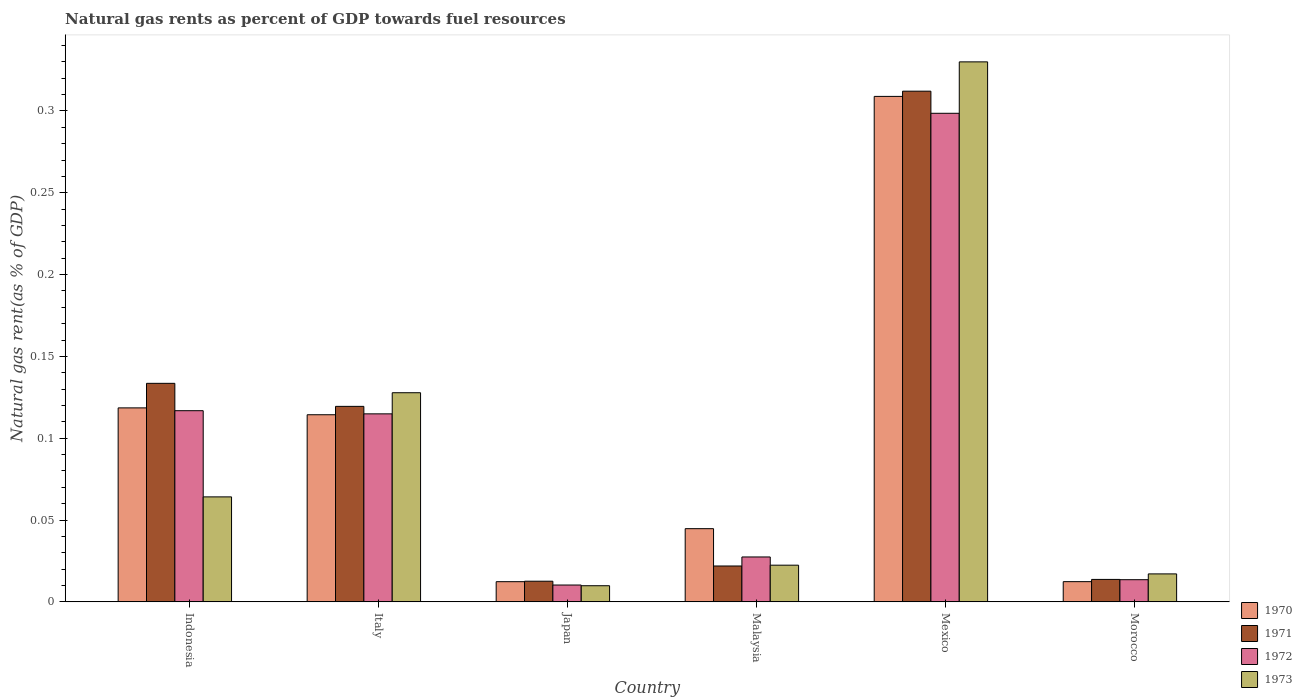Are the number of bars on each tick of the X-axis equal?
Your answer should be very brief. Yes. How many bars are there on the 1st tick from the left?
Keep it short and to the point. 4. How many bars are there on the 4th tick from the right?
Provide a short and direct response. 4. What is the natural gas rent in 1970 in Mexico?
Offer a terse response. 0.31. Across all countries, what is the maximum natural gas rent in 1971?
Ensure brevity in your answer.  0.31. Across all countries, what is the minimum natural gas rent in 1970?
Provide a short and direct response. 0.01. In which country was the natural gas rent in 1972 minimum?
Offer a terse response. Japan. What is the total natural gas rent in 1973 in the graph?
Make the answer very short. 0.57. What is the difference between the natural gas rent in 1970 in Mexico and that in Morocco?
Your answer should be compact. 0.3. What is the difference between the natural gas rent in 1970 in Malaysia and the natural gas rent in 1972 in Indonesia?
Ensure brevity in your answer.  -0.07. What is the average natural gas rent in 1971 per country?
Your answer should be very brief. 0.1. What is the difference between the natural gas rent of/in 1970 and natural gas rent of/in 1973 in Japan?
Offer a very short reply. 0. What is the ratio of the natural gas rent in 1970 in Malaysia to that in Mexico?
Offer a terse response. 0.14. Is the natural gas rent in 1972 in Mexico less than that in Morocco?
Make the answer very short. No. What is the difference between the highest and the second highest natural gas rent in 1970?
Ensure brevity in your answer.  0.19. What is the difference between the highest and the lowest natural gas rent in 1973?
Give a very brief answer. 0.32. In how many countries, is the natural gas rent in 1973 greater than the average natural gas rent in 1973 taken over all countries?
Your answer should be very brief. 2. Is it the case that in every country, the sum of the natural gas rent in 1972 and natural gas rent in 1971 is greater than the sum of natural gas rent in 1973 and natural gas rent in 1970?
Ensure brevity in your answer.  No. What does the 3rd bar from the right in Indonesia represents?
Offer a very short reply. 1971. Is it the case that in every country, the sum of the natural gas rent in 1971 and natural gas rent in 1973 is greater than the natural gas rent in 1972?
Provide a short and direct response. Yes. How many bars are there?
Offer a very short reply. 24. Are the values on the major ticks of Y-axis written in scientific E-notation?
Ensure brevity in your answer.  No. Where does the legend appear in the graph?
Your response must be concise. Bottom right. What is the title of the graph?
Provide a succinct answer. Natural gas rents as percent of GDP towards fuel resources. What is the label or title of the X-axis?
Your answer should be very brief. Country. What is the label or title of the Y-axis?
Your answer should be very brief. Natural gas rent(as % of GDP). What is the Natural gas rent(as % of GDP) in 1970 in Indonesia?
Give a very brief answer. 0.12. What is the Natural gas rent(as % of GDP) in 1971 in Indonesia?
Offer a very short reply. 0.13. What is the Natural gas rent(as % of GDP) of 1972 in Indonesia?
Make the answer very short. 0.12. What is the Natural gas rent(as % of GDP) in 1973 in Indonesia?
Your answer should be very brief. 0.06. What is the Natural gas rent(as % of GDP) of 1970 in Italy?
Give a very brief answer. 0.11. What is the Natural gas rent(as % of GDP) of 1971 in Italy?
Provide a succinct answer. 0.12. What is the Natural gas rent(as % of GDP) in 1972 in Italy?
Offer a very short reply. 0.11. What is the Natural gas rent(as % of GDP) in 1973 in Italy?
Make the answer very short. 0.13. What is the Natural gas rent(as % of GDP) of 1970 in Japan?
Keep it short and to the point. 0.01. What is the Natural gas rent(as % of GDP) of 1971 in Japan?
Keep it short and to the point. 0.01. What is the Natural gas rent(as % of GDP) in 1972 in Japan?
Your answer should be compact. 0.01. What is the Natural gas rent(as % of GDP) of 1973 in Japan?
Your response must be concise. 0.01. What is the Natural gas rent(as % of GDP) of 1970 in Malaysia?
Provide a short and direct response. 0.04. What is the Natural gas rent(as % of GDP) of 1971 in Malaysia?
Offer a terse response. 0.02. What is the Natural gas rent(as % of GDP) of 1972 in Malaysia?
Ensure brevity in your answer.  0.03. What is the Natural gas rent(as % of GDP) of 1973 in Malaysia?
Offer a terse response. 0.02. What is the Natural gas rent(as % of GDP) of 1970 in Mexico?
Provide a succinct answer. 0.31. What is the Natural gas rent(as % of GDP) of 1971 in Mexico?
Give a very brief answer. 0.31. What is the Natural gas rent(as % of GDP) of 1972 in Mexico?
Give a very brief answer. 0.3. What is the Natural gas rent(as % of GDP) in 1973 in Mexico?
Give a very brief answer. 0.33. What is the Natural gas rent(as % of GDP) in 1970 in Morocco?
Offer a terse response. 0.01. What is the Natural gas rent(as % of GDP) of 1971 in Morocco?
Provide a succinct answer. 0.01. What is the Natural gas rent(as % of GDP) of 1972 in Morocco?
Provide a succinct answer. 0.01. What is the Natural gas rent(as % of GDP) in 1973 in Morocco?
Offer a terse response. 0.02. Across all countries, what is the maximum Natural gas rent(as % of GDP) of 1970?
Your response must be concise. 0.31. Across all countries, what is the maximum Natural gas rent(as % of GDP) of 1971?
Make the answer very short. 0.31. Across all countries, what is the maximum Natural gas rent(as % of GDP) in 1972?
Your answer should be very brief. 0.3. Across all countries, what is the maximum Natural gas rent(as % of GDP) in 1973?
Your response must be concise. 0.33. Across all countries, what is the minimum Natural gas rent(as % of GDP) of 1970?
Your response must be concise. 0.01. Across all countries, what is the minimum Natural gas rent(as % of GDP) of 1971?
Your answer should be compact. 0.01. Across all countries, what is the minimum Natural gas rent(as % of GDP) of 1972?
Give a very brief answer. 0.01. Across all countries, what is the minimum Natural gas rent(as % of GDP) in 1973?
Provide a short and direct response. 0.01. What is the total Natural gas rent(as % of GDP) of 1970 in the graph?
Keep it short and to the point. 0.61. What is the total Natural gas rent(as % of GDP) in 1971 in the graph?
Your answer should be very brief. 0.61. What is the total Natural gas rent(as % of GDP) of 1972 in the graph?
Offer a very short reply. 0.58. What is the total Natural gas rent(as % of GDP) of 1973 in the graph?
Make the answer very short. 0.57. What is the difference between the Natural gas rent(as % of GDP) in 1970 in Indonesia and that in Italy?
Your answer should be compact. 0. What is the difference between the Natural gas rent(as % of GDP) of 1971 in Indonesia and that in Italy?
Your answer should be very brief. 0.01. What is the difference between the Natural gas rent(as % of GDP) of 1972 in Indonesia and that in Italy?
Provide a succinct answer. 0. What is the difference between the Natural gas rent(as % of GDP) of 1973 in Indonesia and that in Italy?
Offer a terse response. -0.06. What is the difference between the Natural gas rent(as % of GDP) in 1970 in Indonesia and that in Japan?
Give a very brief answer. 0.11. What is the difference between the Natural gas rent(as % of GDP) of 1971 in Indonesia and that in Japan?
Offer a very short reply. 0.12. What is the difference between the Natural gas rent(as % of GDP) in 1972 in Indonesia and that in Japan?
Provide a short and direct response. 0.11. What is the difference between the Natural gas rent(as % of GDP) in 1973 in Indonesia and that in Japan?
Make the answer very short. 0.05. What is the difference between the Natural gas rent(as % of GDP) of 1970 in Indonesia and that in Malaysia?
Provide a succinct answer. 0.07. What is the difference between the Natural gas rent(as % of GDP) of 1971 in Indonesia and that in Malaysia?
Provide a short and direct response. 0.11. What is the difference between the Natural gas rent(as % of GDP) of 1972 in Indonesia and that in Malaysia?
Offer a terse response. 0.09. What is the difference between the Natural gas rent(as % of GDP) of 1973 in Indonesia and that in Malaysia?
Make the answer very short. 0.04. What is the difference between the Natural gas rent(as % of GDP) of 1970 in Indonesia and that in Mexico?
Offer a terse response. -0.19. What is the difference between the Natural gas rent(as % of GDP) in 1971 in Indonesia and that in Mexico?
Give a very brief answer. -0.18. What is the difference between the Natural gas rent(as % of GDP) in 1972 in Indonesia and that in Mexico?
Ensure brevity in your answer.  -0.18. What is the difference between the Natural gas rent(as % of GDP) in 1973 in Indonesia and that in Mexico?
Your answer should be compact. -0.27. What is the difference between the Natural gas rent(as % of GDP) of 1970 in Indonesia and that in Morocco?
Ensure brevity in your answer.  0.11. What is the difference between the Natural gas rent(as % of GDP) in 1971 in Indonesia and that in Morocco?
Your response must be concise. 0.12. What is the difference between the Natural gas rent(as % of GDP) in 1972 in Indonesia and that in Morocco?
Ensure brevity in your answer.  0.1. What is the difference between the Natural gas rent(as % of GDP) in 1973 in Indonesia and that in Morocco?
Make the answer very short. 0.05. What is the difference between the Natural gas rent(as % of GDP) in 1970 in Italy and that in Japan?
Offer a very short reply. 0.1. What is the difference between the Natural gas rent(as % of GDP) in 1971 in Italy and that in Japan?
Make the answer very short. 0.11. What is the difference between the Natural gas rent(as % of GDP) of 1972 in Italy and that in Japan?
Keep it short and to the point. 0.1. What is the difference between the Natural gas rent(as % of GDP) in 1973 in Italy and that in Japan?
Your answer should be very brief. 0.12. What is the difference between the Natural gas rent(as % of GDP) of 1970 in Italy and that in Malaysia?
Provide a succinct answer. 0.07. What is the difference between the Natural gas rent(as % of GDP) in 1971 in Italy and that in Malaysia?
Your answer should be very brief. 0.1. What is the difference between the Natural gas rent(as % of GDP) in 1972 in Italy and that in Malaysia?
Offer a terse response. 0.09. What is the difference between the Natural gas rent(as % of GDP) in 1973 in Italy and that in Malaysia?
Ensure brevity in your answer.  0.11. What is the difference between the Natural gas rent(as % of GDP) in 1970 in Italy and that in Mexico?
Your answer should be compact. -0.19. What is the difference between the Natural gas rent(as % of GDP) of 1971 in Italy and that in Mexico?
Make the answer very short. -0.19. What is the difference between the Natural gas rent(as % of GDP) in 1972 in Italy and that in Mexico?
Your response must be concise. -0.18. What is the difference between the Natural gas rent(as % of GDP) in 1973 in Italy and that in Mexico?
Make the answer very short. -0.2. What is the difference between the Natural gas rent(as % of GDP) in 1970 in Italy and that in Morocco?
Ensure brevity in your answer.  0.1. What is the difference between the Natural gas rent(as % of GDP) in 1971 in Italy and that in Morocco?
Your answer should be compact. 0.11. What is the difference between the Natural gas rent(as % of GDP) in 1972 in Italy and that in Morocco?
Offer a terse response. 0.1. What is the difference between the Natural gas rent(as % of GDP) in 1973 in Italy and that in Morocco?
Give a very brief answer. 0.11. What is the difference between the Natural gas rent(as % of GDP) of 1970 in Japan and that in Malaysia?
Your response must be concise. -0.03. What is the difference between the Natural gas rent(as % of GDP) of 1971 in Japan and that in Malaysia?
Your answer should be compact. -0.01. What is the difference between the Natural gas rent(as % of GDP) of 1972 in Japan and that in Malaysia?
Your answer should be compact. -0.02. What is the difference between the Natural gas rent(as % of GDP) in 1973 in Japan and that in Malaysia?
Provide a short and direct response. -0.01. What is the difference between the Natural gas rent(as % of GDP) in 1970 in Japan and that in Mexico?
Offer a terse response. -0.3. What is the difference between the Natural gas rent(as % of GDP) in 1971 in Japan and that in Mexico?
Your answer should be compact. -0.3. What is the difference between the Natural gas rent(as % of GDP) in 1972 in Japan and that in Mexico?
Give a very brief answer. -0.29. What is the difference between the Natural gas rent(as % of GDP) in 1973 in Japan and that in Mexico?
Make the answer very short. -0.32. What is the difference between the Natural gas rent(as % of GDP) of 1971 in Japan and that in Morocco?
Offer a very short reply. -0. What is the difference between the Natural gas rent(as % of GDP) of 1972 in Japan and that in Morocco?
Offer a terse response. -0. What is the difference between the Natural gas rent(as % of GDP) of 1973 in Japan and that in Morocco?
Your answer should be compact. -0.01. What is the difference between the Natural gas rent(as % of GDP) in 1970 in Malaysia and that in Mexico?
Provide a short and direct response. -0.26. What is the difference between the Natural gas rent(as % of GDP) in 1971 in Malaysia and that in Mexico?
Provide a short and direct response. -0.29. What is the difference between the Natural gas rent(as % of GDP) of 1972 in Malaysia and that in Mexico?
Offer a very short reply. -0.27. What is the difference between the Natural gas rent(as % of GDP) of 1973 in Malaysia and that in Mexico?
Your answer should be compact. -0.31. What is the difference between the Natural gas rent(as % of GDP) of 1970 in Malaysia and that in Morocco?
Provide a short and direct response. 0.03. What is the difference between the Natural gas rent(as % of GDP) of 1971 in Malaysia and that in Morocco?
Make the answer very short. 0.01. What is the difference between the Natural gas rent(as % of GDP) in 1972 in Malaysia and that in Morocco?
Ensure brevity in your answer.  0.01. What is the difference between the Natural gas rent(as % of GDP) of 1973 in Malaysia and that in Morocco?
Your answer should be compact. 0.01. What is the difference between the Natural gas rent(as % of GDP) of 1970 in Mexico and that in Morocco?
Ensure brevity in your answer.  0.3. What is the difference between the Natural gas rent(as % of GDP) in 1971 in Mexico and that in Morocco?
Provide a short and direct response. 0.3. What is the difference between the Natural gas rent(as % of GDP) of 1972 in Mexico and that in Morocco?
Your answer should be compact. 0.28. What is the difference between the Natural gas rent(as % of GDP) of 1973 in Mexico and that in Morocco?
Provide a short and direct response. 0.31. What is the difference between the Natural gas rent(as % of GDP) in 1970 in Indonesia and the Natural gas rent(as % of GDP) in 1971 in Italy?
Offer a terse response. -0. What is the difference between the Natural gas rent(as % of GDP) of 1970 in Indonesia and the Natural gas rent(as % of GDP) of 1972 in Italy?
Your response must be concise. 0. What is the difference between the Natural gas rent(as % of GDP) of 1970 in Indonesia and the Natural gas rent(as % of GDP) of 1973 in Italy?
Give a very brief answer. -0.01. What is the difference between the Natural gas rent(as % of GDP) of 1971 in Indonesia and the Natural gas rent(as % of GDP) of 1972 in Italy?
Give a very brief answer. 0.02. What is the difference between the Natural gas rent(as % of GDP) of 1971 in Indonesia and the Natural gas rent(as % of GDP) of 1973 in Italy?
Give a very brief answer. 0.01. What is the difference between the Natural gas rent(as % of GDP) of 1972 in Indonesia and the Natural gas rent(as % of GDP) of 1973 in Italy?
Offer a very short reply. -0.01. What is the difference between the Natural gas rent(as % of GDP) in 1970 in Indonesia and the Natural gas rent(as % of GDP) in 1971 in Japan?
Your answer should be compact. 0.11. What is the difference between the Natural gas rent(as % of GDP) of 1970 in Indonesia and the Natural gas rent(as % of GDP) of 1972 in Japan?
Your answer should be very brief. 0.11. What is the difference between the Natural gas rent(as % of GDP) in 1970 in Indonesia and the Natural gas rent(as % of GDP) in 1973 in Japan?
Make the answer very short. 0.11. What is the difference between the Natural gas rent(as % of GDP) in 1971 in Indonesia and the Natural gas rent(as % of GDP) in 1972 in Japan?
Provide a short and direct response. 0.12. What is the difference between the Natural gas rent(as % of GDP) in 1971 in Indonesia and the Natural gas rent(as % of GDP) in 1973 in Japan?
Your response must be concise. 0.12. What is the difference between the Natural gas rent(as % of GDP) of 1972 in Indonesia and the Natural gas rent(as % of GDP) of 1973 in Japan?
Your answer should be very brief. 0.11. What is the difference between the Natural gas rent(as % of GDP) of 1970 in Indonesia and the Natural gas rent(as % of GDP) of 1971 in Malaysia?
Provide a short and direct response. 0.1. What is the difference between the Natural gas rent(as % of GDP) of 1970 in Indonesia and the Natural gas rent(as % of GDP) of 1972 in Malaysia?
Keep it short and to the point. 0.09. What is the difference between the Natural gas rent(as % of GDP) in 1970 in Indonesia and the Natural gas rent(as % of GDP) in 1973 in Malaysia?
Provide a succinct answer. 0.1. What is the difference between the Natural gas rent(as % of GDP) in 1971 in Indonesia and the Natural gas rent(as % of GDP) in 1972 in Malaysia?
Make the answer very short. 0.11. What is the difference between the Natural gas rent(as % of GDP) of 1972 in Indonesia and the Natural gas rent(as % of GDP) of 1973 in Malaysia?
Give a very brief answer. 0.09. What is the difference between the Natural gas rent(as % of GDP) in 1970 in Indonesia and the Natural gas rent(as % of GDP) in 1971 in Mexico?
Offer a very short reply. -0.19. What is the difference between the Natural gas rent(as % of GDP) of 1970 in Indonesia and the Natural gas rent(as % of GDP) of 1972 in Mexico?
Keep it short and to the point. -0.18. What is the difference between the Natural gas rent(as % of GDP) in 1970 in Indonesia and the Natural gas rent(as % of GDP) in 1973 in Mexico?
Give a very brief answer. -0.21. What is the difference between the Natural gas rent(as % of GDP) in 1971 in Indonesia and the Natural gas rent(as % of GDP) in 1972 in Mexico?
Offer a very short reply. -0.17. What is the difference between the Natural gas rent(as % of GDP) of 1971 in Indonesia and the Natural gas rent(as % of GDP) of 1973 in Mexico?
Provide a short and direct response. -0.2. What is the difference between the Natural gas rent(as % of GDP) of 1972 in Indonesia and the Natural gas rent(as % of GDP) of 1973 in Mexico?
Make the answer very short. -0.21. What is the difference between the Natural gas rent(as % of GDP) of 1970 in Indonesia and the Natural gas rent(as % of GDP) of 1971 in Morocco?
Your answer should be very brief. 0.1. What is the difference between the Natural gas rent(as % of GDP) in 1970 in Indonesia and the Natural gas rent(as % of GDP) in 1972 in Morocco?
Your answer should be very brief. 0.1. What is the difference between the Natural gas rent(as % of GDP) in 1970 in Indonesia and the Natural gas rent(as % of GDP) in 1973 in Morocco?
Your answer should be very brief. 0.1. What is the difference between the Natural gas rent(as % of GDP) of 1971 in Indonesia and the Natural gas rent(as % of GDP) of 1972 in Morocco?
Your response must be concise. 0.12. What is the difference between the Natural gas rent(as % of GDP) of 1971 in Indonesia and the Natural gas rent(as % of GDP) of 1973 in Morocco?
Your answer should be very brief. 0.12. What is the difference between the Natural gas rent(as % of GDP) in 1972 in Indonesia and the Natural gas rent(as % of GDP) in 1973 in Morocco?
Your answer should be compact. 0.1. What is the difference between the Natural gas rent(as % of GDP) of 1970 in Italy and the Natural gas rent(as % of GDP) of 1971 in Japan?
Provide a short and direct response. 0.1. What is the difference between the Natural gas rent(as % of GDP) of 1970 in Italy and the Natural gas rent(as % of GDP) of 1972 in Japan?
Your answer should be compact. 0.1. What is the difference between the Natural gas rent(as % of GDP) of 1970 in Italy and the Natural gas rent(as % of GDP) of 1973 in Japan?
Provide a short and direct response. 0.1. What is the difference between the Natural gas rent(as % of GDP) of 1971 in Italy and the Natural gas rent(as % of GDP) of 1972 in Japan?
Your answer should be very brief. 0.11. What is the difference between the Natural gas rent(as % of GDP) in 1971 in Italy and the Natural gas rent(as % of GDP) in 1973 in Japan?
Provide a succinct answer. 0.11. What is the difference between the Natural gas rent(as % of GDP) of 1972 in Italy and the Natural gas rent(as % of GDP) of 1973 in Japan?
Make the answer very short. 0.1. What is the difference between the Natural gas rent(as % of GDP) in 1970 in Italy and the Natural gas rent(as % of GDP) in 1971 in Malaysia?
Provide a succinct answer. 0.09. What is the difference between the Natural gas rent(as % of GDP) in 1970 in Italy and the Natural gas rent(as % of GDP) in 1972 in Malaysia?
Provide a short and direct response. 0.09. What is the difference between the Natural gas rent(as % of GDP) of 1970 in Italy and the Natural gas rent(as % of GDP) of 1973 in Malaysia?
Your answer should be very brief. 0.09. What is the difference between the Natural gas rent(as % of GDP) in 1971 in Italy and the Natural gas rent(as % of GDP) in 1972 in Malaysia?
Provide a succinct answer. 0.09. What is the difference between the Natural gas rent(as % of GDP) in 1971 in Italy and the Natural gas rent(as % of GDP) in 1973 in Malaysia?
Provide a short and direct response. 0.1. What is the difference between the Natural gas rent(as % of GDP) of 1972 in Italy and the Natural gas rent(as % of GDP) of 1973 in Malaysia?
Provide a succinct answer. 0.09. What is the difference between the Natural gas rent(as % of GDP) in 1970 in Italy and the Natural gas rent(as % of GDP) in 1971 in Mexico?
Keep it short and to the point. -0.2. What is the difference between the Natural gas rent(as % of GDP) of 1970 in Italy and the Natural gas rent(as % of GDP) of 1972 in Mexico?
Your response must be concise. -0.18. What is the difference between the Natural gas rent(as % of GDP) in 1970 in Italy and the Natural gas rent(as % of GDP) in 1973 in Mexico?
Provide a succinct answer. -0.22. What is the difference between the Natural gas rent(as % of GDP) of 1971 in Italy and the Natural gas rent(as % of GDP) of 1972 in Mexico?
Your answer should be very brief. -0.18. What is the difference between the Natural gas rent(as % of GDP) in 1971 in Italy and the Natural gas rent(as % of GDP) in 1973 in Mexico?
Provide a succinct answer. -0.21. What is the difference between the Natural gas rent(as % of GDP) in 1972 in Italy and the Natural gas rent(as % of GDP) in 1973 in Mexico?
Give a very brief answer. -0.22. What is the difference between the Natural gas rent(as % of GDP) in 1970 in Italy and the Natural gas rent(as % of GDP) in 1971 in Morocco?
Give a very brief answer. 0.1. What is the difference between the Natural gas rent(as % of GDP) in 1970 in Italy and the Natural gas rent(as % of GDP) in 1972 in Morocco?
Offer a terse response. 0.1. What is the difference between the Natural gas rent(as % of GDP) in 1970 in Italy and the Natural gas rent(as % of GDP) in 1973 in Morocco?
Keep it short and to the point. 0.1. What is the difference between the Natural gas rent(as % of GDP) of 1971 in Italy and the Natural gas rent(as % of GDP) of 1972 in Morocco?
Ensure brevity in your answer.  0.11. What is the difference between the Natural gas rent(as % of GDP) in 1971 in Italy and the Natural gas rent(as % of GDP) in 1973 in Morocco?
Provide a succinct answer. 0.1. What is the difference between the Natural gas rent(as % of GDP) in 1972 in Italy and the Natural gas rent(as % of GDP) in 1973 in Morocco?
Your response must be concise. 0.1. What is the difference between the Natural gas rent(as % of GDP) in 1970 in Japan and the Natural gas rent(as % of GDP) in 1971 in Malaysia?
Your response must be concise. -0.01. What is the difference between the Natural gas rent(as % of GDP) in 1970 in Japan and the Natural gas rent(as % of GDP) in 1972 in Malaysia?
Provide a succinct answer. -0.02. What is the difference between the Natural gas rent(as % of GDP) of 1970 in Japan and the Natural gas rent(as % of GDP) of 1973 in Malaysia?
Offer a very short reply. -0.01. What is the difference between the Natural gas rent(as % of GDP) of 1971 in Japan and the Natural gas rent(as % of GDP) of 1972 in Malaysia?
Your answer should be compact. -0.01. What is the difference between the Natural gas rent(as % of GDP) of 1971 in Japan and the Natural gas rent(as % of GDP) of 1973 in Malaysia?
Provide a short and direct response. -0.01. What is the difference between the Natural gas rent(as % of GDP) in 1972 in Japan and the Natural gas rent(as % of GDP) in 1973 in Malaysia?
Ensure brevity in your answer.  -0.01. What is the difference between the Natural gas rent(as % of GDP) of 1970 in Japan and the Natural gas rent(as % of GDP) of 1971 in Mexico?
Offer a terse response. -0.3. What is the difference between the Natural gas rent(as % of GDP) of 1970 in Japan and the Natural gas rent(as % of GDP) of 1972 in Mexico?
Give a very brief answer. -0.29. What is the difference between the Natural gas rent(as % of GDP) of 1970 in Japan and the Natural gas rent(as % of GDP) of 1973 in Mexico?
Make the answer very short. -0.32. What is the difference between the Natural gas rent(as % of GDP) in 1971 in Japan and the Natural gas rent(as % of GDP) in 1972 in Mexico?
Provide a short and direct response. -0.29. What is the difference between the Natural gas rent(as % of GDP) of 1971 in Japan and the Natural gas rent(as % of GDP) of 1973 in Mexico?
Offer a terse response. -0.32. What is the difference between the Natural gas rent(as % of GDP) in 1972 in Japan and the Natural gas rent(as % of GDP) in 1973 in Mexico?
Give a very brief answer. -0.32. What is the difference between the Natural gas rent(as % of GDP) of 1970 in Japan and the Natural gas rent(as % of GDP) of 1971 in Morocco?
Give a very brief answer. -0. What is the difference between the Natural gas rent(as % of GDP) in 1970 in Japan and the Natural gas rent(as % of GDP) in 1972 in Morocco?
Provide a succinct answer. -0. What is the difference between the Natural gas rent(as % of GDP) in 1970 in Japan and the Natural gas rent(as % of GDP) in 1973 in Morocco?
Your answer should be very brief. -0. What is the difference between the Natural gas rent(as % of GDP) in 1971 in Japan and the Natural gas rent(as % of GDP) in 1972 in Morocco?
Provide a succinct answer. -0. What is the difference between the Natural gas rent(as % of GDP) in 1971 in Japan and the Natural gas rent(as % of GDP) in 1973 in Morocco?
Your answer should be very brief. -0. What is the difference between the Natural gas rent(as % of GDP) of 1972 in Japan and the Natural gas rent(as % of GDP) of 1973 in Morocco?
Your answer should be compact. -0.01. What is the difference between the Natural gas rent(as % of GDP) in 1970 in Malaysia and the Natural gas rent(as % of GDP) in 1971 in Mexico?
Keep it short and to the point. -0.27. What is the difference between the Natural gas rent(as % of GDP) in 1970 in Malaysia and the Natural gas rent(as % of GDP) in 1972 in Mexico?
Provide a short and direct response. -0.25. What is the difference between the Natural gas rent(as % of GDP) of 1970 in Malaysia and the Natural gas rent(as % of GDP) of 1973 in Mexico?
Make the answer very short. -0.29. What is the difference between the Natural gas rent(as % of GDP) of 1971 in Malaysia and the Natural gas rent(as % of GDP) of 1972 in Mexico?
Ensure brevity in your answer.  -0.28. What is the difference between the Natural gas rent(as % of GDP) in 1971 in Malaysia and the Natural gas rent(as % of GDP) in 1973 in Mexico?
Provide a succinct answer. -0.31. What is the difference between the Natural gas rent(as % of GDP) in 1972 in Malaysia and the Natural gas rent(as % of GDP) in 1973 in Mexico?
Provide a short and direct response. -0.3. What is the difference between the Natural gas rent(as % of GDP) in 1970 in Malaysia and the Natural gas rent(as % of GDP) in 1971 in Morocco?
Give a very brief answer. 0.03. What is the difference between the Natural gas rent(as % of GDP) of 1970 in Malaysia and the Natural gas rent(as % of GDP) of 1972 in Morocco?
Your response must be concise. 0.03. What is the difference between the Natural gas rent(as % of GDP) of 1970 in Malaysia and the Natural gas rent(as % of GDP) of 1973 in Morocco?
Your answer should be compact. 0.03. What is the difference between the Natural gas rent(as % of GDP) of 1971 in Malaysia and the Natural gas rent(as % of GDP) of 1972 in Morocco?
Give a very brief answer. 0.01. What is the difference between the Natural gas rent(as % of GDP) of 1971 in Malaysia and the Natural gas rent(as % of GDP) of 1973 in Morocco?
Give a very brief answer. 0. What is the difference between the Natural gas rent(as % of GDP) in 1972 in Malaysia and the Natural gas rent(as % of GDP) in 1973 in Morocco?
Keep it short and to the point. 0.01. What is the difference between the Natural gas rent(as % of GDP) in 1970 in Mexico and the Natural gas rent(as % of GDP) in 1971 in Morocco?
Keep it short and to the point. 0.3. What is the difference between the Natural gas rent(as % of GDP) in 1970 in Mexico and the Natural gas rent(as % of GDP) in 1972 in Morocco?
Ensure brevity in your answer.  0.3. What is the difference between the Natural gas rent(as % of GDP) of 1970 in Mexico and the Natural gas rent(as % of GDP) of 1973 in Morocco?
Provide a short and direct response. 0.29. What is the difference between the Natural gas rent(as % of GDP) in 1971 in Mexico and the Natural gas rent(as % of GDP) in 1972 in Morocco?
Make the answer very short. 0.3. What is the difference between the Natural gas rent(as % of GDP) in 1971 in Mexico and the Natural gas rent(as % of GDP) in 1973 in Morocco?
Your response must be concise. 0.29. What is the difference between the Natural gas rent(as % of GDP) in 1972 in Mexico and the Natural gas rent(as % of GDP) in 1973 in Morocco?
Offer a terse response. 0.28. What is the average Natural gas rent(as % of GDP) of 1970 per country?
Your response must be concise. 0.1. What is the average Natural gas rent(as % of GDP) of 1971 per country?
Your answer should be compact. 0.1. What is the average Natural gas rent(as % of GDP) of 1972 per country?
Make the answer very short. 0.1. What is the average Natural gas rent(as % of GDP) of 1973 per country?
Keep it short and to the point. 0.1. What is the difference between the Natural gas rent(as % of GDP) of 1970 and Natural gas rent(as % of GDP) of 1971 in Indonesia?
Provide a short and direct response. -0.01. What is the difference between the Natural gas rent(as % of GDP) of 1970 and Natural gas rent(as % of GDP) of 1972 in Indonesia?
Your response must be concise. 0. What is the difference between the Natural gas rent(as % of GDP) in 1970 and Natural gas rent(as % of GDP) in 1973 in Indonesia?
Provide a short and direct response. 0.05. What is the difference between the Natural gas rent(as % of GDP) of 1971 and Natural gas rent(as % of GDP) of 1972 in Indonesia?
Make the answer very short. 0.02. What is the difference between the Natural gas rent(as % of GDP) of 1971 and Natural gas rent(as % of GDP) of 1973 in Indonesia?
Ensure brevity in your answer.  0.07. What is the difference between the Natural gas rent(as % of GDP) in 1972 and Natural gas rent(as % of GDP) in 1973 in Indonesia?
Offer a terse response. 0.05. What is the difference between the Natural gas rent(as % of GDP) of 1970 and Natural gas rent(as % of GDP) of 1971 in Italy?
Make the answer very short. -0.01. What is the difference between the Natural gas rent(as % of GDP) in 1970 and Natural gas rent(as % of GDP) in 1972 in Italy?
Keep it short and to the point. -0. What is the difference between the Natural gas rent(as % of GDP) of 1970 and Natural gas rent(as % of GDP) of 1973 in Italy?
Offer a terse response. -0.01. What is the difference between the Natural gas rent(as % of GDP) of 1971 and Natural gas rent(as % of GDP) of 1972 in Italy?
Make the answer very short. 0. What is the difference between the Natural gas rent(as % of GDP) in 1971 and Natural gas rent(as % of GDP) in 1973 in Italy?
Provide a short and direct response. -0.01. What is the difference between the Natural gas rent(as % of GDP) in 1972 and Natural gas rent(as % of GDP) in 1973 in Italy?
Your answer should be compact. -0.01. What is the difference between the Natural gas rent(as % of GDP) in 1970 and Natural gas rent(as % of GDP) in 1971 in Japan?
Make the answer very short. -0. What is the difference between the Natural gas rent(as % of GDP) of 1970 and Natural gas rent(as % of GDP) of 1972 in Japan?
Provide a succinct answer. 0. What is the difference between the Natural gas rent(as % of GDP) in 1970 and Natural gas rent(as % of GDP) in 1973 in Japan?
Provide a short and direct response. 0. What is the difference between the Natural gas rent(as % of GDP) in 1971 and Natural gas rent(as % of GDP) in 1972 in Japan?
Provide a short and direct response. 0. What is the difference between the Natural gas rent(as % of GDP) in 1971 and Natural gas rent(as % of GDP) in 1973 in Japan?
Offer a very short reply. 0. What is the difference between the Natural gas rent(as % of GDP) of 1972 and Natural gas rent(as % of GDP) of 1973 in Japan?
Offer a very short reply. 0. What is the difference between the Natural gas rent(as % of GDP) in 1970 and Natural gas rent(as % of GDP) in 1971 in Malaysia?
Your answer should be compact. 0.02. What is the difference between the Natural gas rent(as % of GDP) in 1970 and Natural gas rent(as % of GDP) in 1972 in Malaysia?
Your response must be concise. 0.02. What is the difference between the Natural gas rent(as % of GDP) of 1970 and Natural gas rent(as % of GDP) of 1973 in Malaysia?
Your response must be concise. 0.02. What is the difference between the Natural gas rent(as % of GDP) in 1971 and Natural gas rent(as % of GDP) in 1972 in Malaysia?
Your answer should be compact. -0.01. What is the difference between the Natural gas rent(as % of GDP) of 1971 and Natural gas rent(as % of GDP) of 1973 in Malaysia?
Your answer should be compact. -0. What is the difference between the Natural gas rent(as % of GDP) of 1972 and Natural gas rent(as % of GDP) of 1973 in Malaysia?
Provide a short and direct response. 0.01. What is the difference between the Natural gas rent(as % of GDP) in 1970 and Natural gas rent(as % of GDP) in 1971 in Mexico?
Make the answer very short. -0. What is the difference between the Natural gas rent(as % of GDP) in 1970 and Natural gas rent(as % of GDP) in 1972 in Mexico?
Offer a very short reply. 0.01. What is the difference between the Natural gas rent(as % of GDP) of 1970 and Natural gas rent(as % of GDP) of 1973 in Mexico?
Your answer should be very brief. -0.02. What is the difference between the Natural gas rent(as % of GDP) of 1971 and Natural gas rent(as % of GDP) of 1972 in Mexico?
Provide a short and direct response. 0.01. What is the difference between the Natural gas rent(as % of GDP) in 1971 and Natural gas rent(as % of GDP) in 1973 in Mexico?
Your answer should be very brief. -0.02. What is the difference between the Natural gas rent(as % of GDP) of 1972 and Natural gas rent(as % of GDP) of 1973 in Mexico?
Offer a terse response. -0.03. What is the difference between the Natural gas rent(as % of GDP) of 1970 and Natural gas rent(as % of GDP) of 1971 in Morocco?
Make the answer very short. -0. What is the difference between the Natural gas rent(as % of GDP) in 1970 and Natural gas rent(as % of GDP) in 1972 in Morocco?
Keep it short and to the point. -0. What is the difference between the Natural gas rent(as % of GDP) in 1970 and Natural gas rent(as % of GDP) in 1973 in Morocco?
Offer a very short reply. -0. What is the difference between the Natural gas rent(as % of GDP) in 1971 and Natural gas rent(as % of GDP) in 1972 in Morocco?
Ensure brevity in your answer.  0. What is the difference between the Natural gas rent(as % of GDP) of 1971 and Natural gas rent(as % of GDP) of 1973 in Morocco?
Provide a succinct answer. -0. What is the difference between the Natural gas rent(as % of GDP) of 1972 and Natural gas rent(as % of GDP) of 1973 in Morocco?
Offer a terse response. -0. What is the ratio of the Natural gas rent(as % of GDP) in 1970 in Indonesia to that in Italy?
Offer a very short reply. 1.04. What is the ratio of the Natural gas rent(as % of GDP) in 1971 in Indonesia to that in Italy?
Offer a very short reply. 1.12. What is the ratio of the Natural gas rent(as % of GDP) in 1972 in Indonesia to that in Italy?
Your answer should be compact. 1.02. What is the ratio of the Natural gas rent(as % of GDP) in 1973 in Indonesia to that in Italy?
Give a very brief answer. 0.5. What is the ratio of the Natural gas rent(as % of GDP) in 1970 in Indonesia to that in Japan?
Your answer should be very brief. 9.61. What is the ratio of the Natural gas rent(as % of GDP) in 1971 in Indonesia to that in Japan?
Keep it short and to the point. 10.58. What is the ratio of the Natural gas rent(as % of GDP) of 1972 in Indonesia to that in Japan?
Give a very brief answer. 11.34. What is the ratio of the Natural gas rent(as % of GDP) of 1973 in Indonesia to that in Japan?
Your answer should be very brief. 6.5. What is the ratio of the Natural gas rent(as % of GDP) of 1970 in Indonesia to that in Malaysia?
Provide a succinct answer. 2.65. What is the ratio of the Natural gas rent(as % of GDP) in 1971 in Indonesia to that in Malaysia?
Keep it short and to the point. 6.09. What is the ratio of the Natural gas rent(as % of GDP) in 1972 in Indonesia to that in Malaysia?
Provide a short and direct response. 4.26. What is the ratio of the Natural gas rent(as % of GDP) of 1973 in Indonesia to that in Malaysia?
Your answer should be compact. 2.86. What is the ratio of the Natural gas rent(as % of GDP) in 1970 in Indonesia to that in Mexico?
Offer a terse response. 0.38. What is the ratio of the Natural gas rent(as % of GDP) of 1971 in Indonesia to that in Mexico?
Make the answer very short. 0.43. What is the ratio of the Natural gas rent(as % of GDP) of 1972 in Indonesia to that in Mexico?
Provide a succinct answer. 0.39. What is the ratio of the Natural gas rent(as % of GDP) of 1973 in Indonesia to that in Mexico?
Make the answer very short. 0.19. What is the ratio of the Natural gas rent(as % of GDP) of 1970 in Indonesia to that in Morocco?
Your response must be concise. 9.59. What is the ratio of the Natural gas rent(as % of GDP) in 1971 in Indonesia to that in Morocco?
Your answer should be compact. 9.73. What is the ratio of the Natural gas rent(as % of GDP) of 1972 in Indonesia to that in Morocco?
Offer a terse response. 8.62. What is the ratio of the Natural gas rent(as % of GDP) of 1973 in Indonesia to that in Morocco?
Provide a short and direct response. 3.75. What is the ratio of the Natural gas rent(as % of GDP) of 1970 in Italy to that in Japan?
Keep it short and to the point. 9.27. What is the ratio of the Natural gas rent(as % of GDP) of 1971 in Italy to that in Japan?
Your answer should be compact. 9.46. What is the ratio of the Natural gas rent(as % of GDP) in 1972 in Italy to that in Japan?
Make the answer very short. 11.16. What is the ratio of the Natural gas rent(as % of GDP) in 1973 in Italy to that in Japan?
Your response must be concise. 12.96. What is the ratio of the Natural gas rent(as % of GDP) of 1970 in Italy to that in Malaysia?
Your response must be concise. 2.56. What is the ratio of the Natural gas rent(as % of GDP) of 1971 in Italy to that in Malaysia?
Your answer should be very brief. 5.45. What is the ratio of the Natural gas rent(as % of GDP) of 1972 in Italy to that in Malaysia?
Give a very brief answer. 4.19. What is the ratio of the Natural gas rent(as % of GDP) in 1973 in Italy to that in Malaysia?
Your answer should be compact. 5.7. What is the ratio of the Natural gas rent(as % of GDP) of 1970 in Italy to that in Mexico?
Make the answer very short. 0.37. What is the ratio of the Natural gas rent(as % of GDP) of 1971 in Italy to that in Mexico?
Your answer should be compact. 0.38. What is the ratio of the Natural gas rent(as % of GDP) in 1972 in Italy to that in Mexico?
Offer a very short reply. 0.38. What is the ratio of the Natural gas rent(as % of GDP) of 1973 in Italy to that in Mexico?
Make the answer very short. 0.39. What is the ratio of the Natural gas rent(as % of GDP) of 1970 in Italy to that in Morocco?
Your answer should be very brief. 9.25. What is the ratio of the Natural gas rent(as % of GDP) of 1971 in Italy to that in Morocco?
Your response must be concise. 8.7. What is the ratio of the Natural gas rent(as % of GDP) in 1972 in Italy to that in Morocco?
Your answer should be very brief. 8.48. What is the ratio of the Natural gas rent(as % of GDP) in 1973 in Italy to that in Morocco?
Your answer should be very brief. 7.47. What is the ratio of the Natural gas rent(as % of GDP) in 1970 in Japan to that in Malaysia?
Offer a terse response. 0.28. What is the ratio of the Natural gas rent(as % of GDP) in 1971 in Japan to that in Malaysia?
Keep it short and to the point. 0.58. What is the ratio of the Natural gas rent(as % of GDP) of 1972 in Japan to that in Malaysia?
Keep it short and to the point. 0.38. What is the ratio of the Natural gas rent(as % of GDP) in 1973 in Japan to that in Malaysia?
Your response must be concise. 0.44. What is the ratio of the Natural gas rent(as % of GDP) in 1970 in Japan to that in Mexico?
Your response must be concise. 0.04. What is the ratio of the Natural gas rent(as % of GDP) of 1971 in Japan to that in Mexico?
Your response must be concise. 0.04. What is the ratio of the Natural gas rent(as % of GDP) of 1972 in Japan to that in Mexico?
Your response must be concise. 0.03. What is the ratio of the Natural gas rent(as % of GDP) in 1973 in Japan to that in Mexico?
Your answer should be compact. 0.03. What is the ratio of the Natural gas rent(as % of GDP) in 1970 in Japan to that in Morocco?
Make the answer very short. 1. What is the ratio of the Natural gas rent(as % of GDP) in 1971 in Japan to that in Morocco?
Your answer should be very brief. 0.92. What is the ratio of the Natural gas rent(as % of GDP) of 1972 in Japan to that in Morocco?
Provide a succinct answer. 0.76. What is the ratio of the Natural gas rent(as % of GDP) of 1973 in Japan to that in Morocco?
Your answer should be compact. 0.58. What is the ratio of the Natural gas rent(as % of GDP) in 1970 in Malaysia to that in Mexico?
Offer a very short reply. 0.14. What is the ratio of the Natural gas rent(as % of GDP) in 1971 in Malaysia to that in Mexico?
Provide a short and direct response. 0.07. What is the ratio of the Natural gas rent(as % of GDP) of 1972 in Malaysia to that in Mexico?
Your response must be concise. 0.09. What is the ratio of the Natural gas rent(as % of GDP) of 1973 in Malaysia to that in Mexico?
Ensure brevity in your answer.  0.07. What is the ratio of the Natural gas rent(as % of GDP) in 1970 in Malaysia to that in Morocco?
Offer a terse response. 3.62. What is the ratio of the Natural gas rent(as % of GDP) of 1971 in Malaysia to that in Morocco?
Ensure brevity in your answer.  1.6. What is the ratio of the Natural gas rent(as % of GDP) in 1972 in Malaysia to that in Morocco?
Provide a short and direct response. 2.03. What is the ratio of the Natural gas rent(as % of GDP) in 1973 in Malaysia to that in Morocco?
Provide a short and direct response. 1.31. What is the ratio of the Natural gas rent(as % of GDP) in 1970 in Mexico to that in Morocco?
Your answer should be very brief. 25. What is the ratio of the Natural gas rent(as % of GDP) of 1971 in Mexico to that in Morocco?
Your answer should be very brief. 22.74. What is the ratio of the Natural gas rent(as % of GDP) of 1972 in Mexico to that in Morocco?
Provide a succinct answer. 22.04. What is the ratio of the Natural gas rent(as % of GDP) in 1973 in Mexico to that in Morocco?
Your response must be concise. 19.3. What is the difference between the highest and the second highest Natural gas rent(as % of GDP) in 1970?
Give a very brief answer. 0.19. What is the difference between the highest and the second highest Natural gas rent(as % of GDP) in 1971?
Your response must be concise. 0.18. What is the difference between the highest and the second highest Natural gas rent(as % of GDP) of 1972?
Provide a succinct answer. 0.18. What is the difference between the highest and the second highest Natural gas rent(as % of GDP) in 1973?
Keep it short and to the point. 0.2. What is the difference between the highest and the lowest Natural gas rent(as % of GDP) in 1970?
Your response must be concise. 0.3. What is the difference between the highest and the lowest Natural gas rent(as % of GDP) in 1971?
Your response must be concise. 0.3. What is the difference between the highest and the lowest Natural gas rent(as % of GDP) of 1972?
Make the answer very short. 0.29. What is the difference between the highest and the lowest Natural gas rent(as % of GDP) of 1973?
Offer a terse response. 0.32. 